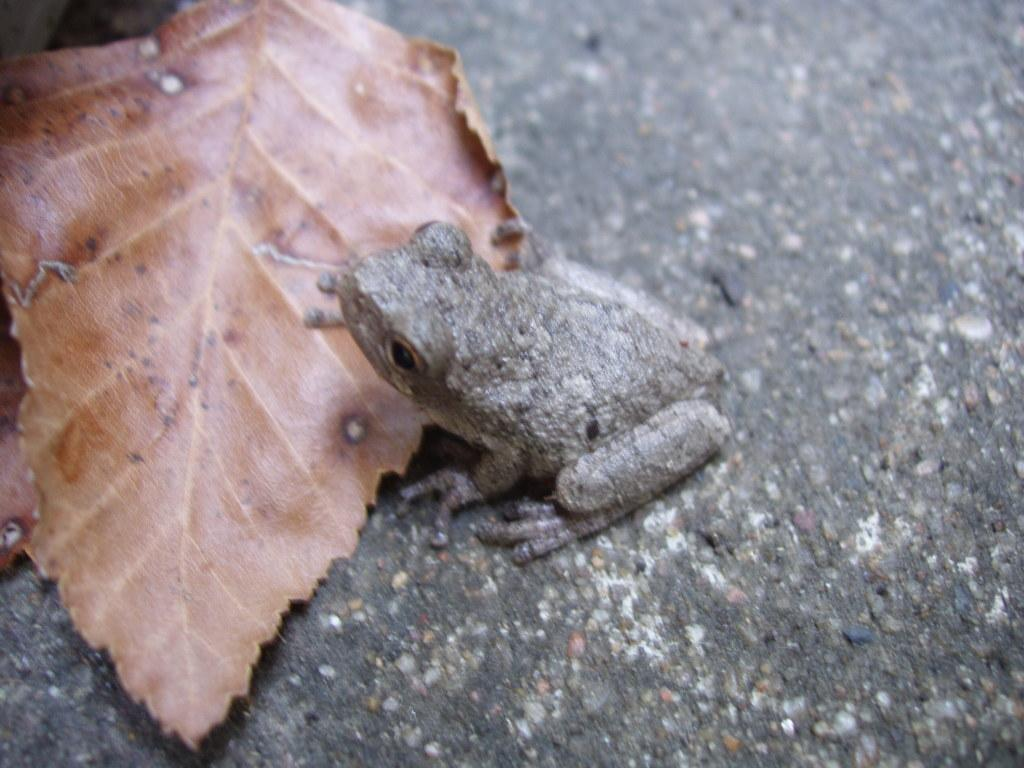What type of animal is present in the image? There is a frog in the image. What is located behind the frog in the image? There is a leaf behind the frog in the image. What type of sponge is being used to clean the frog's nails in the image? There is no sponge or nail present in the image; it features a frog and a leaf. 